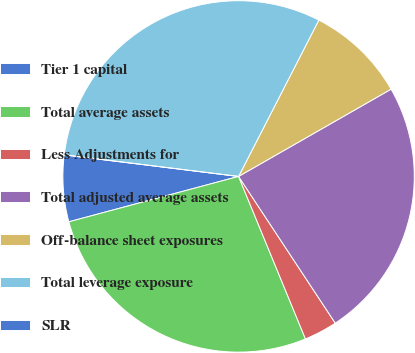Convert chart. <chart><loc_0><loc_0><loc_500><loc_500><pie_chart><fcel>Tier 1 capital<fcel>Total average assets<fcel>Less Adjustments for<fcel>Total adjusted average assets<fcel>Off-balance sheet exposures<fcel>Total leverage exposure<fcel>SLR<nl><fcel>6.12%<fcel>27.06%<fcel>3.06%<fcel>24.0%<fcel>9.18%<fcel>30.59%<fcel>0.0%<nl></chart> 